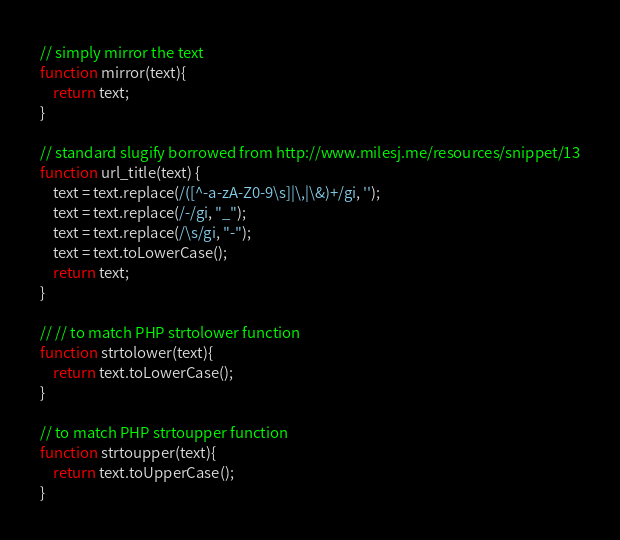<code> <loc_0><loc_0><loc_500><loc_500><_JavaScript_>// simply mirror the text
function mirror(text){
	return text;
}

// standard slugify borrowed from http://www.milesj.me/resources/snippet/13
function url_title(text) {
	text = text.replace(/([^-a-zA-Z0-9\s]|\,|\&)+/gi, '');
	text = text.replace(/-/gi, "_");
	text = text.replace(/\s/gi, "-");
	text = text.toLowerCase();
	return text;
}

// // to match PHP strtolower function
function strtolower(text){
	return text.toLowerCase();	
}

// to match PHP strtoupper function
function strtoupper(text){
	return text.toUpperCase();
}
</code> 